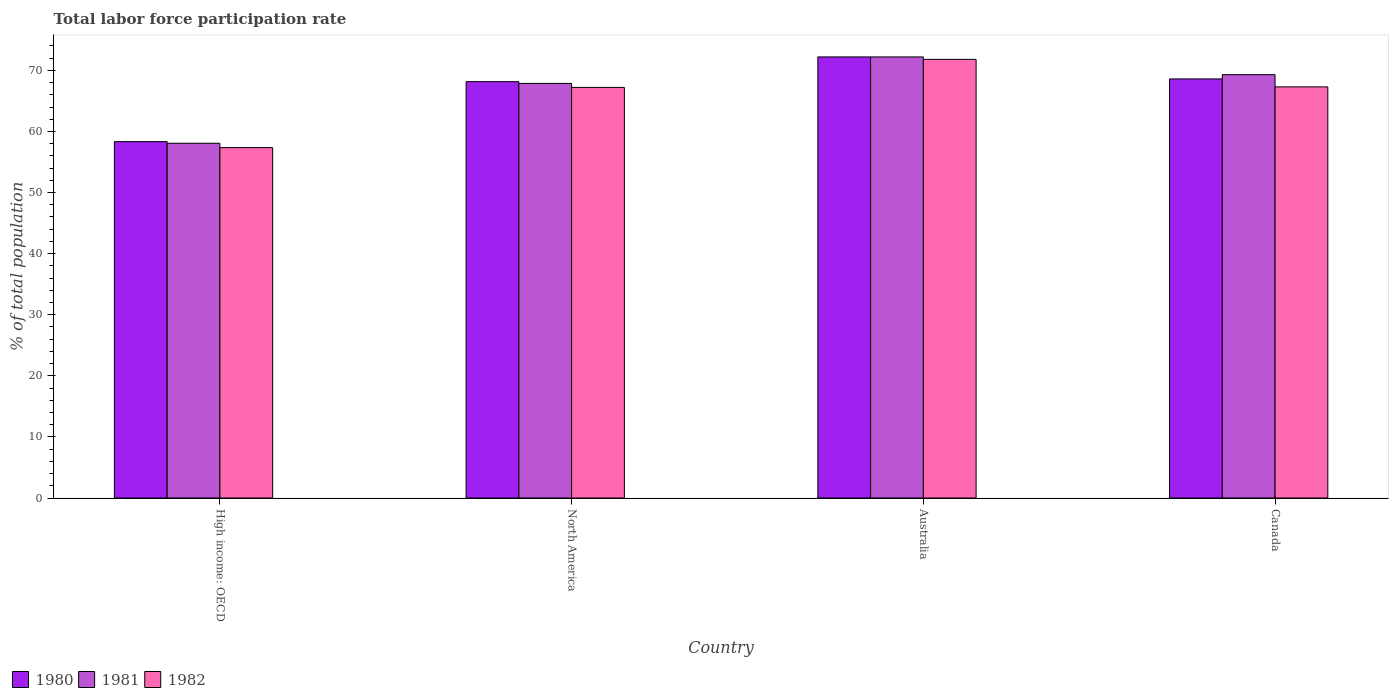How many groups of bars are there?
Provide a succinct answer. 4. Are the number of bars on each tick of the X-axis equal?
Your answer should be very brief. Yes. How many bars are there on the 2nd tick from the right?
Offer a terse response. 3. What is the label of the 3rd group of bars from the left?
Offer a terse response. Australia. What is the total labor force participation rate in 1981 in High income: OECD?
Your answer should be very brief. 58.07. Across all countries, what is the maximum total labor force participation rate in 1980?
Offer a terse response. 72.2. Across all countries, what is the minimum total labor force participation rate in 1980?
Give a very brief answer. 58.34. In which country was the total labor force participation rate in 1982 minimum?
Keep it short and to the point. High income: OECD. What is the total total labor force participation rate in 1980 in the graph?
Keep it short and to the point. 267.29. What is the difference between the total labor force participation rate in 1982 in Canada and that in North America?
Your response must be concise. 0.09. What is the difference between the total labor force participation rate in 1982 in North America and the total labor force participation rate in 1981 in High income: OECD?
Your response must be concise. 9.14. What is the average total labor force participation rate in 1982 per country?
Your response must be concise. 65.92. What is the difference between the total labor force participation rate of/in 1981 and total labor force participation rate of/in 1982 in Australia?
Your answer should be very brief. 0.4. In how many countries, is the total labor force participation rate in 1982 greater than 48 %?
Offer a very short reply. 4. What is the ratio of the total labor force participation rate in 1982 in Canada to that in High income: OECD?
Keep it short and to the point. 1.17. What is the difference between the highest and the second highest total labor force participation rate in 1980?
Offer a terse response. 3.6. What is the difference between the highest and the lowest total labor force participation rate in 1982?
Your answer should be very brief. 14.45. In how many countries, is the total labor force participation rate in 1980 greater than the average total labor force participation rate in 1980 taken over all countries?
Your response must be concise. 3. What does the 3rd bar from the left in Canada represents?
Your answer should be very brief. 1982. Is it the case that in every country, the sum of the total labor force participation rate in 1981 and total labor force participation rate in 1982 is greater than the total labor force participation rate in 1980?
Make the answer very short. Yes. How many countries are there in the graph?
Your answer should be compact. 4. What is the difference between two consecutive major ticks on the Y-axis?
Make the answer very short. 10. Are the values on the major ticks of Y-axis written in scientific E-notation?
Your response must be concise. No. Does the graph contain any zero values?
Offer a terse response. No. Where does the legend appear in the graph?
Keep it short and to the point. Bottom left. How many legend labels are there?
Provide a succinct answer. 3. What is the title of the graph?
Your answer should be very brief. Total labor force participation rate. What is the label or title of the Y-axis?
Offer a terse response. % of total population. What is the % of total population in 1980 in High income: OECD?
Offer a very short reply. 58.34. What is the % of total population in 1981 in High income: OECD?
Offer a very short reply. 58.07. What is the % of total population of 1982 in High income: OECD?
Provide a succinct answer. 57.35. What is the % of total population in 1980 in North America?
Make the answer very short. 68.15. What is the % of total population of 1981 in North America?
Make the answer very short. 67.86. What is the % of total population in 1982 in North America?
Make the answer very short. 67.21. What is the % of total population of 1980 in Australia?
Offer a terse response. 72.2. What is the % of total population in 1981 in Australia?
Offer a very short reply. 72.2. What is the % of total population in 1982 in Australia?
Provide a succinct answer. 71.8. What is the % of total population of 1980 in Canada?
Provide a succinct answer. 68.6. What is the % of total population in 1981 in Canada?
Keep it short and to the point. 69.3. What is the % of total population of 1982 in Canada?
Keep it short and to the point. 67.3. Across all countries, what is the maximum % of total population of 1980?
Your answer should be very brief. 72.2. Across all countries, what is the maximum % of total population in 1981?
Your answer should be very brief. 72.2. Across all countries, what is the maximum % of total population of 1982?
Offer a terse response. 71.8. Across all countries, what is the minimum % of total population in 1980?
Offer a very short reply. 58.34. Across all countries, what is the minimum % of total population of 1981?
Your answer should be compact. 58.07. Across all countries, what is the minimum % of total population in 1982?
Ensure brevity in your answer.  57.35. What is the total % of total population in 1980 in the graph?
Provide a succinct answer. 267.29. What is the total % of total population in 1981 in the graph?
Offer a terse response. 267.43. What is the total % of total population in 1982 in the graph?
Offer a terse response. 263.66. What is the difference between the % of total population of 1980 in High income: OECD and that in North America?
Make the answer very short. -9.81. What is the difference between the % of total population of 1981 in High income: OECD and that in North America?
Ensure brevity in your answer.  -9.8. What is the difference between the % of total population in 1982 in High income: OECD and that in North America?
Your response must be concise. -9.86. What is the difference between the % of total population in 1980 in High income: OECD and that in Australia?
Offer a very short reply. -13.86. What is the difference between the % of total population in 1981 in High income: OECD and that in Australia?
Provide a short and direct response. -14.13. What is the difference between the % of total population in 1982 in High income: OECD and that in Australia?
Your answer should be very brief. -14.45. What is the difference between the % of total population in 1980 in High income: OECD and that in Canada?
Offer a very short reply. -10.26. What is the difference between the % of total population in 1981 in High income: OECD and that in Canada?
Make the answer very short. -11.23. What is the difference between the % of total population of 1982 in High income: OECD and that in Canada?
Your answer should be compact. -9.95. What is the difference between the % of total population in 1980 in North America and that in Australia?
Make the answer very short. -4.05. What is the difference between the % of total population in 1981 in North America and that in Australia?
Keep it short and to the point. -4.34. What is the difference between the % of total population of 1982 in North America and that in Australia?
Your response must be concise. -4.59. What is the difference between the % of total population of 1980 in North America and that in Canada?
Keep it short and to the point. -0.45. What is the difference between the % of total population of 1981 in North America and that in Canada?
Your answer should be compact. -1.44. What is the difference between the % of total population of 1982 in North America and that in Canada?
Ensure brevity in your answer.  -0.09. What is the difference between the % of total population in 1980 in Australia and that in Canada?
Ensure brevity in your answer.  3.6. What is the difference between the % of total population in 1980 in High income: OECD and the % of total population in 1981 in North America?
Your response must be concise. -9.53. What is the difference between the % of total population of 1980 in High income: OECD and the % of total population of 1982 in North America?
Your answer should be compact. -8.87. What is the difference between the % of total population of 1981 in High income: OECD and the % of total population of 1982 in North America?
Offer a very short reply. -9.14. What is the difference between the % of total population in 1980 in High income: OECD and the % of total population in 1981 in Australia?
Your answer should be very brief. -13.86. What is the difference between the % of total population of 1980 in High income: OECD and the % of total population of 1982 in Australia?
Provide a succinct answer. -13.46. What is the difference between the % of total population of 1981 in High income: OECD and the % of total population of 1982 in Australia?
Give a very brief answer. -13.73. What is the difference between the % of total population in 1980 in High income: OECD and the % of total population in 1981 in Canada?
Ensure brevity in your answer.  -10.96. What is the difference between the % of total population of 1980 in High income: OECD and the % of total population of 1982 in Canada?
Offer a very short reply. -8.96. What is the difference between the % of total population in 1981 in High income: OECD and the % of total population in 1982 in Canada?
Make the answer very short. -9.23. What is the difference between the % of total population of 1980 in North America and the % of total population of 1981 in Australia?
Your answer should be compact. -4.05. What is the difference between the % of total population in 1980 in North America and the % of total population in 1982 in Australia?
Provide a short and direct response. -3.65. What is the difference between the % of total population of 1981 in North America and the % of total population of 1982 in Australia?
Your answer should be very brief. -3.94. What is the difference between the % of total population in 1980 in North America and the % of total population in 1981 in Canada?
Give a very brief answer. -1.15. What is the difference between the % of total population in 1980 in North America and the % of total population in 1982 in Canada?
Make the answer very short. 0.85. What is the difference between the % of total population of 1981 in North America and the % of total population of 1982 in Canada?
Offer a very short reply. 0.56. What is the average % of total population in 1980 per country?
Provide a short and direct response. 66.82. What is the average % of total population of 1981 per country?
Offer a terse response. 66.86. What is the average % of total population of 1982 per country?
Your response must be concise. 65.92. What is the difference between the % of total population in 1980 and % of total population in 1981 in High income: OECD?
Offer a terse response. 0.27. What is the difference between the % of total population in 1980 and % of total population in 1982 in High income: OECD?
Offer a terse response. 0.98. What is the difference between the % of total population in 1981 and % of total population in 1982 in High income: OECD?
Your answer should be compact. 0.71. What is the difference between the % of total population of 1980 and % of total population of 1981 in North America?
Your answer should be very brief. 0.29. What is the difference between the % of total population in 1980 and % of total population in 1982 in North America?
Provide a succinct answer. 0.94. What is the difference between the % of total population in 1981 and % of total population in 1982 in North America?
Give a very brief answer. 0.65. What is the difference between the % of total population of 1980 and % of total population of 1981 in Australia?
Make the answer very short. 0. What is the difference between the % of total population of 1980 and % of total population of 1982 in Australia?
Offer a terse response. 0.4. What is the difference between the % of total population of 1980 and % of total population of 1981 in Canada?
Provide a succinct answer. -0.7. What is the ratio of the % of total population in 1980 in High income: OECD to that in North America?
Your response must be concise. 0.86. What is the ratio of the % of total population in 1981 in High income: OECD to that in North America?
Your answer should be compact. 0.86. What is the ratio of the % of total population of 1982 in High income: OECD to that in North America?
Ensure brevity in your answer.  0.85. What is the ratio of the % of total population of 1980 in High income: OECD to that in Australia?
Offer a terse response. 0.81. What is the ratio of the % of total population in 1981 in High income: OECD to that in Australia?
Make the answer very short. 0.8. What is the ratio of the % of total population of 1982 in High income: OECD to that in Australia?
Your answer should be compact. 0.8. What is the ratio of the % of total population of 1980 in High income: OECD to that in Canada?
Make the answer very short. 0.85. What is the ratio of the % of total population of 1981 in High income: OECD to that in Canada?
Your response must be concise. 0.84. What is the ratio of the % of total population in 1982 in High income: OECD to that in Canada?
Your answer should be very brief. 0.85. What is the ratio of the % of total population of 1980 in North America to that in Australia?
Provide a short and direct response. 0.94. What is the ratio of the % of total population in 1981 in North America to that in Australia?
Offer a terse response. 0.94. What is the ratio of the % of total population of 1982 in North America to that in Australia?
Keep it short and to the point. 0.94. What is the ratio of the % of total population in 1980 in North America to that in Canada?
Give a very brief answer. 0.99. What is the ratio of the % of total population of 1981 in North America to that in Canada?
Offer a very short reply. 0.98. What is the ratio of the % of total population in 1980 in Australia to that in Canada?
Provide a succinct answer. 1.05. What is the ratio of the % of total population in 1981 in Australia to that in Canada?
Make the answer very short. 1.04. What is the ratio of the % of total population of 1982 in Australia to that in Canada?
Your answer should be very brief. 1.07. What is the difference between the highest and the second highest % of total population of 1980?
Keep it short and to the point. 3.6. What is the difference between the highest and the second highest % of total population in 1981?
Offer a terse response. 2.9. What is the difference between the highest and the second highest % of total population of 1982?
Offer a terse response. 4.5. What is the difference between the highest and the lowest % of total population in 1980?
Your answer should be compact. 13.86. What is the difference between the highest and the lowest % of total population in 1981?
Make the answer very short. 14.13. What is the difference between the highest and the lowest % of total population in 1982?
Make the answer very short. 14.45. 